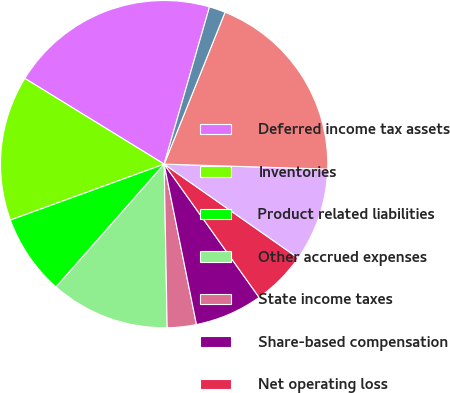<chart> <loc_0><loc_0><loc_500><loc_500><pie_chart><fcel>Deferred income tax assets<fcel>Inventories<fcel>Product related liabilities<fcel>Other accrued expenses<fcel>State income taxes<fcel>Share-based compensation<fcel>Net operating loss<fcel>Other<fcel>Total deferred income tax<fcel>Less valuation allowances<nl><fcel>20.69%<fcel>14.33%<fcel>7.96%<fcel>11.78%<fcel>2.87%<fcel>6.69%<fcel>5.42%<fcel>9.24%<fcel>19.42%<fcel>1.6%<nl></chart> 